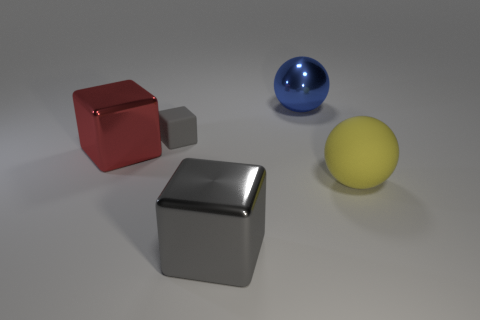Are there any other things that have the same size as the gray matte block?
Ensure brevity in your answer.  No. There is a yellow matte ball in front of the large ball behind the large yellow rubber ball; what number of metallic things are in front of it?
Provide a succinct answer. 1. What number of other objects are the same material as the large gray thing?
Your response must be concise. 2. What material is the red block that is the same size as the yellow rubber thing?
Keep it short and to the point. Metal. Do the matte thing that is to the left of the blue thing and the big block to the right of the red metal object have the same color?
Provide a short and direct response. Yes. Are there any yellow matte objects of the same shape as the blue metallic object?
Your response must be concise. Yes. There is a yellow rubber thing that is the same size as the red cube; what shape is it?
Make the answer very short. Sphere. What number of spheres have the same color as the small cube?
Your answer should be compact. 0. How big is the ball on the right side of the blue metallic object?
Keep it short and to the point. Large. What number of yellow rubber objects are the same size as the red shiny object?
Make the answer very short. 1. 